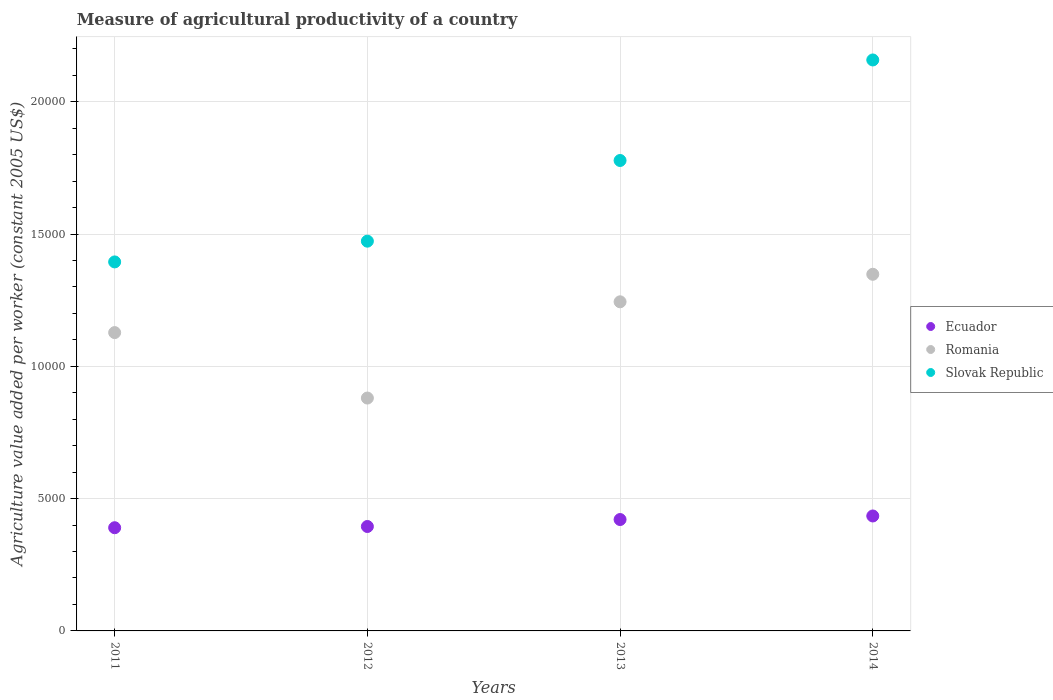What is the measure of agricultural productivity in Slovak Republic in 2012?
Give a very brief answer. 1.47e+04. Across all years, what is the maximum measure of agricultural productivity in Romania?
Your answer should be compact. 1.35e+04. Across all years, what is the minimum measure of agricultural productivity in Slovak Republic?
Give a very brief answer. 1.39e+04. In which year was the measure of agricultural productivity in Romania minimum?
Provide a short and direct response. 2012. What is the total measure of agricultural productivity in Ecuador in the graph?
Make the answer very short. 1.64e+04. What is the difference between the measure of agricultural productivity in Slovak Republic in 2013 and that in 2014?
Provide a short and direct response. -3799.11. What is the difference between the measure of agricultural productivity in Romania in 2011 and the measure of agricultural productivity in Slovak Republic in 2014?
Provide a short and direct response. -1.03e+04. What is the average measure of agricultural productivity in Slovak Republic per year?
Your response must be concise. 1.70e+04. In the year 2014, what is the difference between the measure of agricultural productivity in Slovak Republic and measure of agricultural productivity in Romania?
Your answer should be compact. 8099.52. What is the ratio of the measure of agricultural productivity in Ecuador in 2012 to that in 2014?
Offer a very short reply. 0.91. Is the measure of agricultural productivity in Romania in 2011 less than that in 2012?
Your response must be concise. No. What is the difference between the highest and the second highest measure of agricultural productivity in Romania?
Your answer should be compact. 1039.72. What is the difference between the highest and the lowest measure of agricultural productivity in Slovak Republic?
Your response must be concise. 7632.3. In how many years, is the measure of agricultural productivity in Romania greater than the average measure of agricultural productivity in Romania taken over all years?
Make the answer very short. 2. Is the sum of the measure of agricultural productivity in Slovak Republic in 2011 and 2013 greater than the maximum measure of agricultural productivity in Romania across all years?
Give a very brief answer. Yes. Is it the case that in every year, the sum of the measure of agricultural productivity in Slovak Republic and measure of agricultural productivity in Romania  is greater than the measure of agricultural productivity in Ecuador?
Your answer should be very brief. Yes. Is the measure of agricultural productivity in Romania strictly less than the measure of agricultural productivity in Ecuador over the years?
Give a very brief answer. No. How many years are there in the graph?
Your response must be concise. 4. Does the graph contain grids?
Ensure brevity in your answer.  Yes. How many legend labels are there?
Your response must be concise. 3. How are the legend labels stacked?
Offer a very short reply. Vertical. What is the title of the graph?
Your answer should be very brief. Measure of agricultural productivity of a country. Does "Cote d'Ivoire" appear as one of the legend labels in the graph?
Provide a short and direct response. No. What is the label or title of the Y-axis?
Keep it short and to the point. Agriculture value added per worker (constant 2005 US$). What is the Agriculture value added per worker (constant 2005 US$) of Ecuador in 2011?
Ensure brevity in your answer.  3900.13. What is the Agriculture value added per worker (constant 2005 US$) in Romania in 2011?
Offer a terse response. 1.13e+04. What is the Agriculture value added per worker (constant 2005 US$) of Slovak Republic in 2011?
Keep it short and to the point. 1.39e+04. What is the Agriculture value added per worker (constant 2005 US$) in Ecuador in 2012?
Your answer should be very brief. 3946.49. What is the Agriculture value added per worker (constant 2005 US$) of Romania in 2012?
Your answer should be compact. 8800.17. What is the Agriculture value added per worker (constant 2005 US$) in Slovak Republic in 2012?
Make the answer very short. 1.47e+04. What is the Agriculture value added per worker (constant 2005 US$) of Ecuador in 2013?
Your response must be concise. 4209.62. What is the Agriculture value added per worker (constant 2005 US$) in Romania in 2013?
Ensure brevity in your answer.  1.24e+04. What is the Agriculture value added per worker (constant 2005 US$) in Slovak Republic in 2013?
Ensure brevity in your answer.  1.78e+04. What is the Agriculture value added per worker (constant 2005 US$) in Ecuador in 2014?
Provide a short and direct response. 4343.94. What is the Agriculture value added per worker (constant 2005 US$) of Romania in 2014?
Ensure brevity in your answer.  1.35e+04. What is the Agriculture value added per worker (constant 2005 US$) of Slovak Republic in 2014?
Offer a very short reply. 2.16e+04. Across all years, what is the maximum Agriculture value added per worker (constant 2005 US$) of Ecuador?
Ensure brevity in your answer.  4343.94. Across all years, what is the maximum Agriculture value added per worker (constant 2005 US$) in Romania?
Offer a terse response. 1.35e+04. Across all years, what is the maximum Agriculture value added per worker (constant 2005 US$) of Slovak Republic?
Your answer should be compact. 2.16e+04. Across all years, what is the minimum Agriculture value added per worker (constant 2005 US$) in Ecuador?
Provide a short and direct response. 3900.13. Across all years, what is the minimum Agriculture value added per worker (constant 2005 US$) of Romania?
Keep it short and to the point. 8800.17. Across all years, what is the minimum Agriculture value added per worker (constant 2005 US$) of Slovak Republic?
Ensure brevity in your answer.  1.39e+04. What is the total Agriculture value added per worker (constant 2005 US$) in Ecuador in the graph?
Ensure brevity in your answer.  1.64e+04. What is the total Agriculture value added per worker (constant 2005 US$) in Romania in the graph?
Ensure brevity in your answer.  4.60e+04. What is the total Agriculture value added per worker (constant 2005 US$) of Slovak Republic in the graph?
Offer a terse response. 6.80e+04. What is the difference between the Agriculture value added per worker (constant 2005 US$) of Ecuador in 2011 and that in 2012?
Give a very brief answer. -46.36. What is the difference between the Agriculture value added per worker (constant 2005 US$) in Romania in 2011 and that in 2012?
Your answer should be very brief. 2473.92. What is the difference between the Agriculture value added per worker (constant 2005 US$) in Slovak Republic in 2011 and that in 2012?
Make the answer very short. -784.3. What is the difference between the Agriculture value added per worker (constant 2005 US$) in Ecuador in 2011 and that in 2013?
Your answer should be very brief. -309.5. What is the difference between the Agriculture value added per worker (constant 2005 US$) of Romania in 2011 and that in 2013?
Your answer should be compact. -1163.93. What is the difference between the Agriculture value added per worker (constant 2005 US$) in Slovak Republic in 2011 and that in 2013?
Your answer should be compact. -3833.18. What is the difference between the Agriculture value added per worker (constant 2005 US$) of Ecuador in 2011 and that in 2014?
Make the answer very short. -443.81. What is the difference between the Agriculture value added per worker (constant 2005 US$) in Romania in 2011 and that in 2014?
Keep it short and to the point. -2203.65. What is the difference between the Agriculture value added per worker (constant 2005 US$) of Slovak Republic in 2011 and that in 2014?
Your answer should be compact. -7632.3. What is the difference between the Agriculture value added per worker (constant 2005 US$) in Ecuador in 2012 and that in 2013?
Ensure brevity in your answer.  -263.13. What is the difference between the Agriculture value added per worker (constant 2005 US$) of Romania in 2012 and that in 2013?
Your answer should be compact. -3637.86. What is the difference between the Agriculture value added per worker (constant 2005 US$) of Slovak Republic in 2012 and that in 2013?
Your answer should be compact. -3048.88. What is the difference between the Agriculture value added per worker (constant 2005 US$) in Ecuador in 2012 and that in 2014?
Make the answer very short. -397.45. What is the difference between the Agriculture value added per worker (constant 2005 US$) in Romania in 2012 and that in 2014?
Give a very brief answer. -4677.58. What is the difference between the Agriculture value added per worker (constant 2005 US$) in Slovak Republic in 2012 and that in 2014?
Your answer should be compact. -6847.99. What is the difference between the Agriculture value added per worker (constant 2005 US$) of Ecuador in 2013 and that in 2014?
Provide a succinct answer. -134.32. What is the difference between the Agriculture value added per worker (constant 2005 US$) in Romania in 2013 and that in 2014?
Your answer should be compact. -1039.72. What is the difference between the Agriculture value added per worker (constant 2005 US$) of Slovak Republic in 2013 and that in 2014?
Make the answer very short. -3799.11. What is the difference between the Agriculture value added per worker (constant 2005 US$) in Ecuador in 2011 and the Agriculture value added per worker (constant 2005 US$) in Romania in 2012?
Your answer should be very brief. -4900.04. What is the difference between the Agriculture value added per worker (constant 2005 US$) in Ecuador in 2011 and the Agriculture value added per worker (constant 2005 US$) in Slovak Republic in 2012?
Make the answer very short. -1.08e+04. What is the difference between the Agriculture value added per worker (constant 2005 US$) of Romania in 2011 and the Agriculture value added per worker (constant 2005 US$) of Slovak Republic in 2012?
Your answer should be compact. -3455.18. What is the difference between the Agriculture value added per worker (constant 2005 US$) of Ecuador in 2011 and the Agriculture value added per worker (constant 2005 US$) of Romania in 2013?
Offer a very short reply. -8537.9. What is the difference between the Agriculture value added per worker (constant 2005 US$) in Ecuador in 2011 and the Agriculture value added per worker (constant 2005 US$) in Slovak Republic in 2013?
Provide a succinct answer. -1.39e+04. What is the difference between the Agriculture value added per worker (constant 2005 US$) of Romania in 2011 and the Agriculture value added per worker (constant 2005 US$) of Slovak Republic in 2013?
Ensure brevity in your answer.  -6504.07. What is the difference between the Agriculture value added per worker (constant 2005 US$) in Ecuador in 2011 and the Agriculture value added per worker (constant 2005 US$) in Romania in 2014?
Keep it short and to the point. -9577.62. What is the difference between the Agriculture value added per worker (constant 2005 US$) of Ecuador in 2011 and the Agriculture value added per worker (constant 2005 US$) of Slovak Republic in 2014?
Keep it short and to the point. -1.77e+04. What is the difference between the Agriculture value added per worker (constant 2005 US$) of Romania in 2011 and the Agriculture value added per worker (constant 2005 US$) of Slovak Republic in 2014?
Your answer should be compact. -1.03e+04. What is the difference between the Agriculture value added per worker (constant 2005 US$) in Ecuador in 2012 and the Agriculture value added per worker (constant 2005 US$) in Romania in 2013?
Your answer should be compact. -8491.54. What is the difference between the Agriculture value added per worker (constant 2005 US$) in Ecuador in 2012 and the Agriculture value added per worker (constant 2005 US$) in Slovak Republic in 2013?
Your answer should be compact. -1.38e+04. What is the difference between the Agriculture value added per worker (constant 2005 US$) of Romania in 2012 and the Agriculture value added per worker (constant 2005 US$) of Slovak Republic in 2013?
Your answer should be very brief. -8977.99. What is the difference between the Agriculture value added per worker (constant 2005 US$) in Ecuador in 2012 and the Agriculture value added per worker (constant 2005 US$) in Romania in 2014?
Give a very brief answer. -9531.26. What is the difference between the Agriculture value added per worker (constant 2005 US$) of Ecuador in 2012 and the Agriculture value added per worker (constant 2005 US$) of Slovak Republic in 2014?
Your response must be concise. -1.76e+04. What is the difference between the Agriculture value added per worker (constant 2005 US$) in Romania in 2012 and the Agriculture value added per worker (constant 2005 US$) in Slovak Republic in 2014?
Offer a terse response. -1.28e+04. What is the difference between the Agriculture value added per worker (constant 2005 US$) in Ecuador in 2013 and the Agriculture value added per worker (constant 2005 US$) in Romania in 2014?
Make the answer very short. -9268.13. What is the difference between the Agriculture value added per worker (constant 2005 US$) of Ecuador in 2013 and the Agriculture value added per worker (constant 2005 US$) of Slovak Republic in 2014?
Provide a succinct answer. -1.74e+04. What is the difference between the Agriculture value added per worker (constant 2005 US$) of Romania in 2013 and the Agriculture value added per worker (constant 2005 US$) of Slovak Republic in 2014?
Offer a terse response. -9139.24. What is the average Agriculture value added per worker (constant 2005 US$) in Ecuador per year?
Provide a short and direct response. 4100.04. What is the average Agriculture value added per worker (constant 2005 US$) of Romania per year?
Your answer should be compact. 1.15e+04. What is the average Agriculture value added per worker (constant 2005 US$) in Slovak Republic per year?
Your answer should be compact. 1.70e+04. In the year 2011, what is the difference between the Agriculture value added per worker (constant 2005 US$) of Ecuador and Agriculture value added per worker (constant 2005 US$) of Romania?
Keep it short and to the point. -7373.97. In the year 2011, what is the difference between the Agriculture value added per worker (constant 2005 US$) in Ecuador and Agriculture value added per worker (constant 2005 US$) in Slovak Republic?
Keep it short and to the point. -1.00e+04. In the year 2011, what is the difference between the Agriculture value added per worker (constant 2005 US$) of Romania and Agriculture value added per worker (constant 2005 US$) of Slovak Republic?
Give a very brief answer. -2670.88. In the year 2012, what is the difference between the Agriculture value added per worker (constant 2005 US$) in Ecuador and Agriculture value added per worker (constant 2005 US$) in Romania?
Make the answer very short. -4853.68. In the year 2012, what is the difference between the Agriculture value added per worker (constant 2005 US$) in Ecuador and Agriculture value added per worker (constant 2005 US$) in Slovak Republic?
Provide a short and direct response. -1.08e+04. In the year 2012, what is the difference between the Agriculture value added per worker (constant 2005 US$) in Romania and Agriculture value added per worker (constant 2005 US$) in Slovak Republic?
Give a very brief answer. -5929.11. In the year 2013, what is the difference between the Agriculture value added per worker (constant 2005 US$) in Ecuador and Agriculture value added per worker (constant 2005 US$) in Romania?
Your answer should be compact. -8228.41. In the year 2013, what is the difference between the Agriculture value added per worker (constant 2005 US$) of Ecuador and Agriculture value added per worker (constant 2005 US$) of Slovak Republic?
Give a very brief answer. -1.36e+04. In the year 2013, what is the difference between the Agriculture value added per worker (constant 2005 US$) in Romania and Agriculture value added per worker (constant 2005 US$) in Slovak Republic?
Ensure brevity in your answer.  -5340.13. In the year 2014, what is the difference between the Agriculture value added per worker (constant 2005 US$) of Ecuador and Agriculture value added per worker (constant 2005 US$) of Romania?
Offer a very short reply. -9133.81. In the year 2014, what is the difference between the Agriculture value added per worker (constant 2005 US$) of Ecuador and Agriculture value added per worker (constant 2005 US$) of Slovak Republic?
Offer a terse response. -1.72e+04. In the year 2014, what is the difference between the Agriculture value added per worker (constant 2005 US$) in Romania and Agriculture value added per worker (constant 2005 US$) in Slovak Republic?
Offer a terse response. -8099.52. What is the ratio of the Agriculture value added per worker (constant 2005 US$) in Ecuador in 2011 to that in 2012?
Provide a succinct answer. 0.99. What is the ratio of the Agriculture value added per worker (constant 2005 US$) of Romania in 2011 to that in 2012?
Keep it short and to the point. 1.28. What is the ratio of the Agriculture value added per worker (constant 2005 US$) in Slovak Republic in 2011 to that in 2012?
Offer a terse response. 0.95. What is the ratio of the Agriculture value added per worker (constant 2005 US$) of Ecuador in 2011 to that in 2013?
Offer a terse response. 0.93. What is the ratio of the Agriculture value added per worker (constant 2005 US$) of Romania in 2011 to that in 2013?
Ensure brevity in your answer.  0.91. What is the ratio of the Agriculture value added per worker (constant 2005 US$) in Slovak Republic in 2011 to that in 2013?
Provide a succinct answer. 0.78. What is the ratio of the Agriculture value added per worker (constant 2005 US$) of Ecuador in 2011 to that in 2014?
Offer a terse response. 0.9. What is the ratio of the Agriculture value added per worker (constant 2005 US$) of Romania in 2011 to that in 2014?
Offer a terse response. 0.84. What is the ratio of the Agriculture value added per worker (constant 2005 US$) of Slovak Republic in 2011 to that in 2014?
Your answer should be compact. 0.65. What is the ratio of the Agriculture value added per worker (constant 2005 US$) of Romania in 2012 to that in 2013?
Your response must be concise. 0.71. What is the ratio of the Agriculture value added per worker (constant 2005 US$) in Slovak Republic in 2012 to that in 2013?
Your answer should be compact. 0.83. What is the ratio of the Agriculture value added per worker (constant 2005 US$) in Ecuador in 2012 to that in 2014?
Offer a terse response. 0.91. What is the ratio of the Agriculture value added per worker (constant 2005 US$) of Romania in 2012 to that in 2014?
Give a very brief answer. 0.65. What is the ratio of the Agriculture value added per worker (constant 2005 US$) of Slovak Republic in 2012 to that in 2014?
Offer a terse response. 0.68. What is the ratio of the Agriculture value added per worker (constant 2005 US$) in Ecuador in 2013 to that in 2014?
Your answer should be very brief. 0.97. What is the ratio of the Agriculture value added per worker (constant 2005 US$) of Romania in 2013 to that in 2014?
Offer a terse response. 0.92. What is the ratio of the Agriculture value added per worker (constant 2005 US$) of Slovak Republic in 2013 to that in 2014?
Offer a very short reply. 0.82. What is the difference between the highest and the second highest Agriculture value added per worker (constant 2005 US$) of Ecuador?
Offer a terse response. 134.32. What is the difference between the highest and the second highest Agriculture value added per worker (constant 2005 US$) of Romania?
Your response must be concise. 1039.72. What is the difference between the highest and the second highest Agriculture value added per worker (constant 2005 US$) of Slovak Republic?
Ensure brevity in your answer.  3799.11. What is the difference between the highest and the lowest Agriculture value added per worker (constant 2005 US$) of Ecuador?
Offer a very short reply. 443.81. What is the difference between the highest and the lowest Agriculture value added per worker (constant 2005 US$) in Romania?
Offer a very short reply. 4677.58. What is the difference between the highest and the lowest Agriculture value added per worker (constant 2005 US$) of Slovak Republic?
Give a very brief answer. 7632.3. 